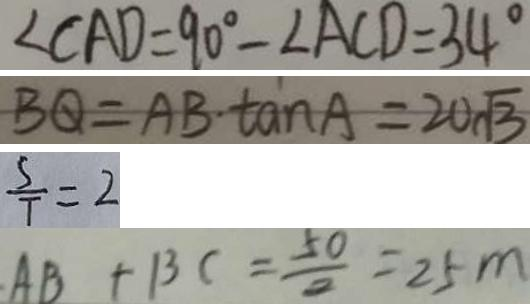Convert formula to latex. <formula><loc_0><loc_0><loc_500><loc_500>\angle C A D = 9 0 ^ { \circ } - \angle A C D = 3 4 ^ { \circ } 
 B Q = A B \cdot \tan A = 2 0 \sqrt { 3 } 
 \frac { S } { T } = 2 
 A B + B C = \frac { 5 0 } { 2 } = 2 5 m</formula> 